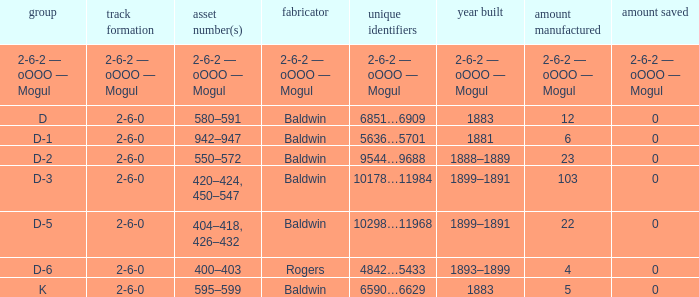What is the quantity made when the class is d-2? 23.0. 